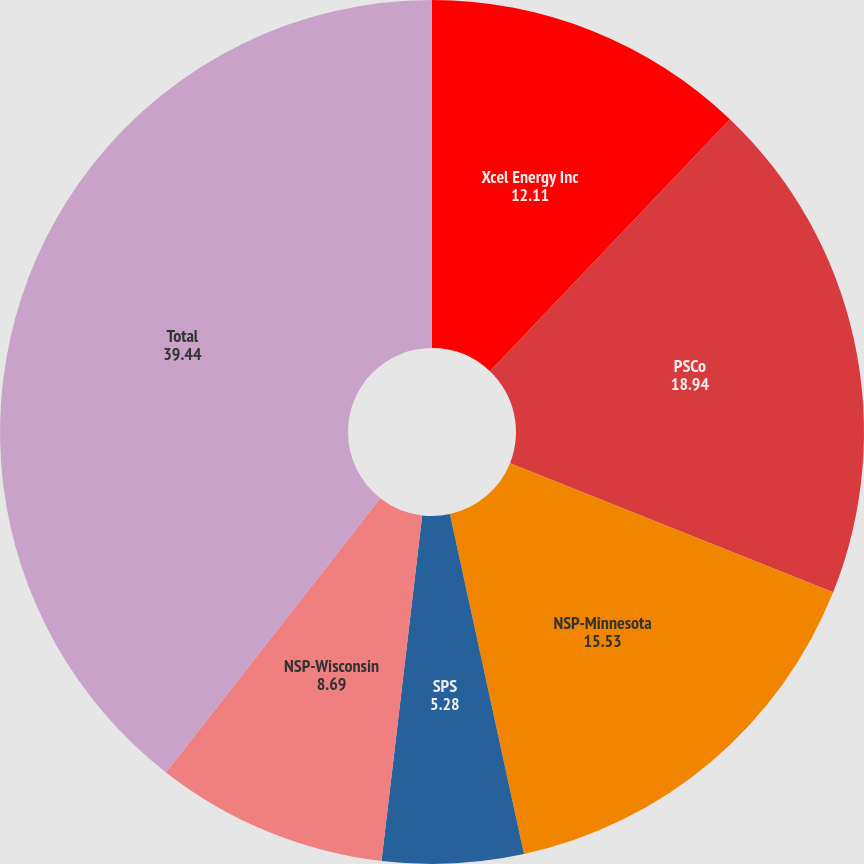<chart> <loc_0><loc_0><loc_500><loc_500><pie_chart><fcel>Xcel Energy Inc<fcel>PSCo<fcel>NSP-Minnesota<fcel>SPS<fcel>NSP-Wisconsin<fcel>Total<nl><fcel>12.11%<fcel>18.94%<fcel>15.53%<fcel>5.28%<fcel>8.69%<fcel>39.44%<nl></chart> 